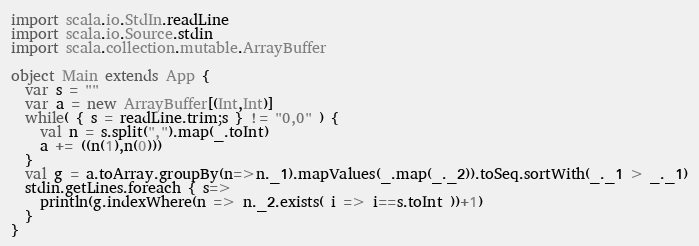<code> <loc_0><loc_0><loc_500><loc_500><_Scala_>import scala.io.StdIn.readLine
import scala.io.Source.stdin
import scala.collection.mutable.ArrayBuffer

object Main extends App {
  var s = ""
  var a = new ArrayBuffer[(Int,Int)]
  while( { s = readLine.trim;s } != "0,0" ) {
    val n = s.split(",").map(_.toInt)
    a += ((n(1),n(0)))
  }
  val g = a.toArray.groupBy(n=>n._1).mapValues(_.map(_._2)).toSeq.sortWith(_._1 > _._1)
  stdin.getLines.foreach { s=>
    println(g.indexWhere(n => n._2.exists( i => i==s.toInt ))+1)
  }
}</code> 